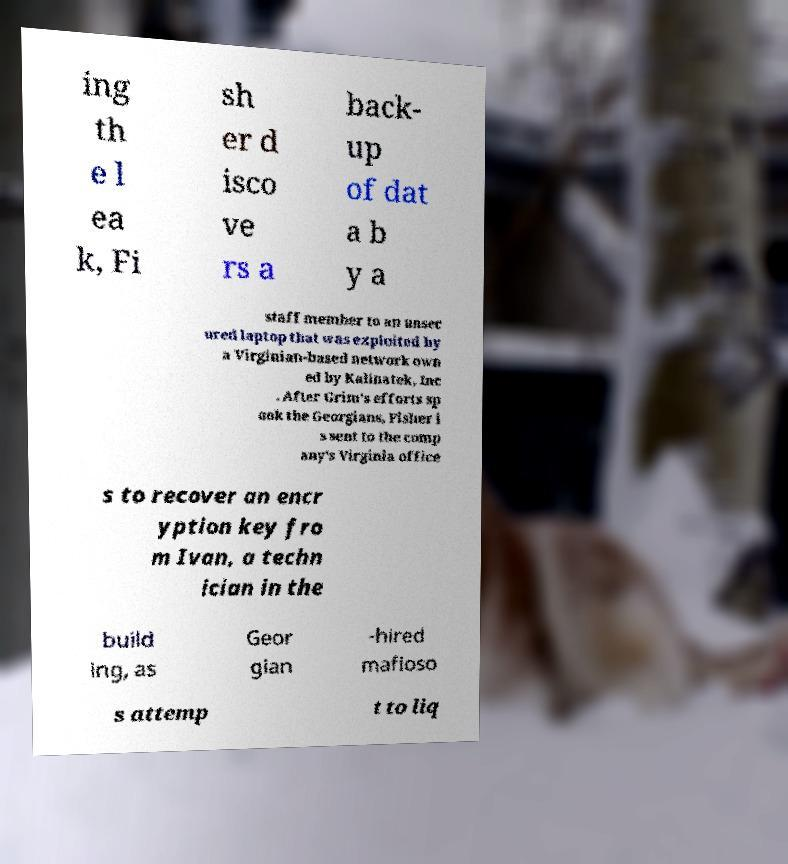Can you accurately transcribe the text from the provided image for me? ing th e l ea k, Fi sh er d isco ve rs a back- up of dat a b y a staff member to an unsec ured laptop that was exploited by a Virginian-based network own ed by Kalinatek, Inc . After Grim's efforts sp ook the Georgians, Fisher i s sent to the comp any's Virginia office s to recover an encr yption key fro m Ivan, a techn ician in the build ing, as Geor gian -hired mafioso s attemp t to liq 